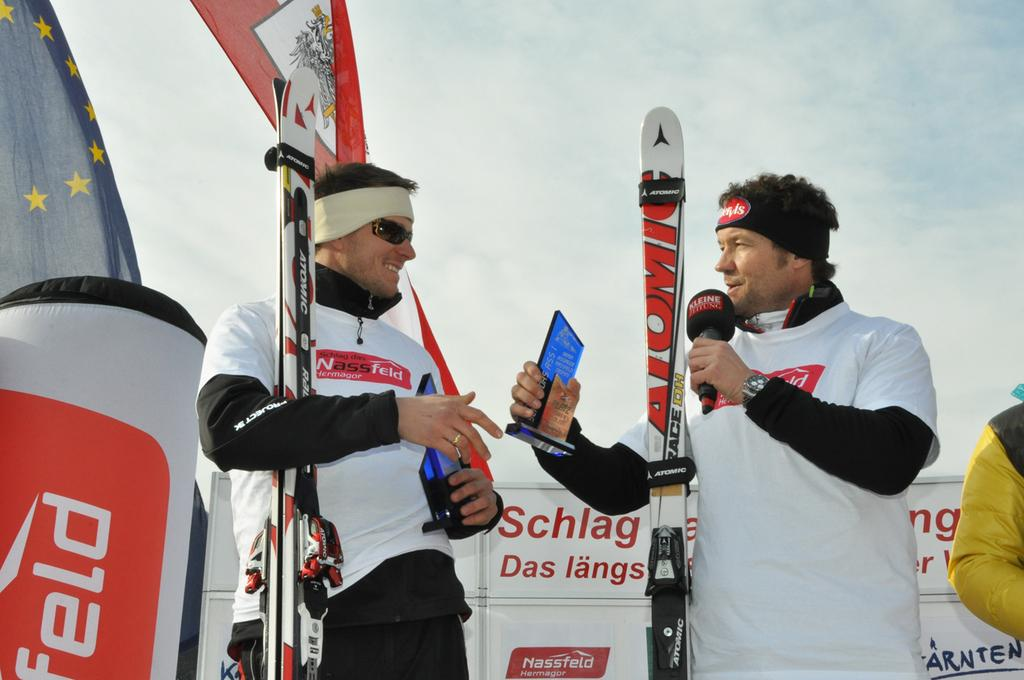How many people are in the image? There are two persons in the image. What are the persons doing in the image? The persons are standing and holding ski boards in their hands. What can be seen in the background of the image? There is a sky, a flag, and banners visible in the background of the image. What type of sack is being used to carry the pencils in the image? There are no sacks or pencils present in the image. 